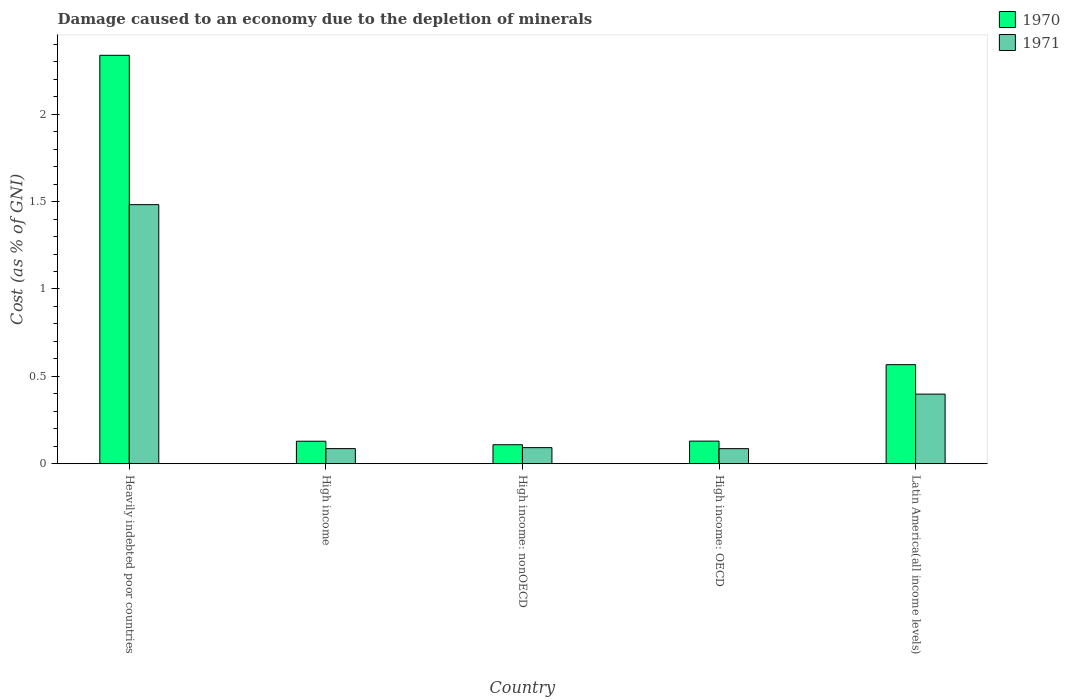How many different coloured bars are there?
Give a very brief answer. 2. Are the number of bars per tick equal to the number of legend labels?
Make the answer very short. Yes. Are the number of bars on each tick of the X-axis equal?
Give a very brief answer. Yes. What is the label of the 5th group of bars from the left?
Offer a very short reply. Latin America(all income levels). What is the cost of damage caused due to the depletion of minerals in 1971 in High income: nonOECD?
Offer a terse response. 0.09. Across all countries, what is the maximum cost of damage caused due to the depletion of minerals in 1971?
Keep it short and to the point. 1.48. Across all countries, what is the minimum cost of damage caused due to the depletion of minerals in 1970?
Your answer should be compact. 0.11. In which country was the cost of damage caused due to the depletion of minerals in 1970 maximum?
Provide a succinct answer. Heavily indebted poor countries. In which country was the cost of damage caused due to the depletion of minerals in 1971 minimum?
Make the answer very short. High income: OECD. What is the total cost of damage caused due to the depletion of minerals in 1970 in the graph?
Make the answer very short. 3.27. What is the difference between the cost of damage caused due to the depletion of minerals in 1971 in Heavily indebted poor countries and that in High income?
Ensure brevity in your answer.  1.4. What is the difference between the cost of damage caused due to the depletion of minerals in 1970 in Latin America(all income levels) and the cost of damage caused due to the depletion of minerals in 1971 in High income: nonOECD?
Offer a terse response. 0.47. What is the average cost of damage caused due to the depletion of minerals in 1971 per country?
Offer a very short reply. 0.43. What is the difference between the cost of damage caused due to the depletion of minerals of/in 1970 and cost of damage caused due to the depletion of minerals of/in 1971 in Heavily indebted poor countries?
Provide a short and direct response. 0.85. In how many countries, is the cost of damage caused due to the depletion of minerals in 1970 greater than 2.1 %?
Your answer should be very brief. 1. What is the ratio of the cost of damage caused due to the depletion of minerals in 1971 in Heavily indebted poor countries to that in High income?
Provide a succinct answer. 17.13. Is the cost of damage caused due to the depletion of minerals in 1971 in High income less than that in High income: OECD?
Offer a terse response. No. Is the difference between the cost of damage caused due to the depletion of minerals in 1970 in High income: nonOECD and Latin America(all income levels) greater than the difference between the cost of damage caused due to the depletion of minerals in 1971 in High income: nonOECD and Latin America(all income levels)?
Offer a terse response. No. What is the difference between the highest and the second highest cost of damage caused due to the depletion of minerals in 1970?
Provide a short and direct response. 0.44. What is the difference between the highest and the lowest cost of damage caused due to the depletion of minerals in 1970?
Your response must be concise. 2.23. What does the 1st bar from the left in High income: nonOECD represents?
Offer a very short reply. 1970. What does the 2nd bar from the right in High income: OECD represents?
Make the answer very short. 1970. How many bars are there?
Give a very brief answer. 10. Are all the bars in the graph horizontal?
Keep it short and to the point. No. How many countries are there in the graph?
Keep it short and to the point. 5. What is the difference between two consecutive major ticks on the Y-axis?
Make the answer very short. 0.5. Are the values on the major ticks of Y-axis written in scientific E-notation?
Provide a short and direct response. No. Where does the legend appear in the graph?
Your answer should be very brief. Top right. How many legend labels are there?
Offer a terse response. 2. How are the legend labels stacked?
Provide a succinct answer. Vertical. What is the title of the graph?
Provide a succinct answer. Damage caused to an economy due to the depletion of minerals. What is the label or title of the X-axis?
Keep it short and to the point. Country. What is the label or title of the Y-axis?
Your answer should be compact. Cost (as % of GNI). What is the Cost (as % of GNI) of 1970 in Heavily indebted poor countries?
Your answer should be very brief. 2.34. What is the Cost (as % of GNI) in 1971 in Heavily indebted poor countries?
Keep it short and to the point. 1.48. What is the Cost (as % of GNI) in 1970 in High income?
Offer a terse response. 0.13. What is the Cost (as % of GNI) in 1971 in High income?
Offer a terse response. 0.09. What is the Cost (as % of GNI) in 1970 in High income: nonOECD?
Give a very brief answer. 0.11. What is the Cost (as % of GNI) of 1971 in High income: nonOECD?
Keep it short and to the point. 0.09. What is the Cost (as % of GNI) in 1970 in High income: OECD?
Provide a succinct answer. 0.13. What is the Cost (as % of GNI) of 1971 in High income: OECD?
Offer a terse response. 0.09. What is the Cost (as % of GNI) of 1970 in Latin America(all income levels)?
Provide a succinct answer. 0.57. What is the Cost (as % of GNI) in 1971 in Latin America(all income levels)?
Give a very brief answer. 0.4. Across all countries, what is the maximum Cost (as % of GNI) of 1970?
Your response must be concise. 2.34. Across all countries, what is the maximum Cost (as % of GNI) of 1971?
Offer a very short reply. 1.48. Across all countries, what is the minimum Cost (as % of GNI) of 1970?
Keep it short and to the point. 0.11. Across all countries, what is the minimum Cost (as % of GNI) in 1971?
Keep it short and to the point. 0.09. What is the total Cost (as % of GNI) in 1970 in the graph?
Provide a succinct answer. 3.27. What is the total Cost (as % of GNI) of 1971 in the graph?
Your response must be concise. 2.15. What is the difference between the Cost (as % of GNI) in 1970 in Heavily indebted poor countries and that in High income?
Keep it short and to the point. 2.21. What is the difference between the Cost (as % of GNI) in 1971 in Heavily indebted poor countries and that in High income?
Offer a very short reply. 1.4. What is the difference between the Cost (as % of GNI) of 1970 in Heavily indebted poor countries and that in High income: nonOECD?
Your answer should be very brief. 2.23. What is the difference between the Cost (as % of GNI) of 1971 in Heavily indebted poor countries and that in High income: nonOECD?
Offer a terse response. 1.39. What is the difference between the Cost (as % of GNI) in 1970 in Heavily indebted poor countries and that in High income: OECD?
Your response must be concise. 2.21. What is the difference between the Cost (as % of GNI) of 1971 in Heavily indebted poor countries and that in High income: OECD?
Your answer should be very brief. 1.4. What is the difference between the Cost (as % of GNI) in 1970 in Heavily indebted poor countries and that in Latin America(all income levels)?
Your answer should be very brief. 1.77. What is the difference between the Cost (as % of GNI) of 1971 in Heavily indebted poor countries and that in Latin America(all income levels)?
Your answer should be compact. 1.08. What is the difference between the Cost (as % of GNI) in 1971 in High income and that in High income: nonOECD?
Offer a terse response. -0.01. What is the difference between the Cost (as % of GNI) of 1970 in High income and that in High income: OECD?
Your response must be concise. -0. What is the difference between the Cost (as % of GNI) of 1971 in High income and that in High income: OECD?
Your response must be concise. 0. What is the difference between the Cost (as % of GNI) of 1970 in High income and that in Latin America(all income levels)?
Your response must be concise. -0.44. What is the difference between the Cost (as % of GNI) of 1971 in High income and that in Latin America(all income levels)?
Ensure brevity in your answer.  -0.31. What is the difference between the Cost (as % of GNI) of 1970 in High income: nonOECD and that in High income: OECD?
Ensure brevity in your answer.  -0.02. What is the difference between the Cost (as % of GNI) of 1971 in High income: nonOECD and that in High income: OECD?
Make the answer very short. 0.01. What is the difference between the Cost (as % of GNI) of 1970 in High income: nonOECD and that in Latin America(all income levels)?
Your answer should be compact. -0.46. What is the difference between the Cost (as % of GNI) of 1971 in High income: nonOECD and that in Latin America(all income levels)?
Provide a short and direct response. -0.31. What is the difference between the Cost (as % of GNI) in 1970 in High income: OECD and that in Latin America(all income levels)?
Give a very brief answer. -0.44. What is the difference between the Cost (as % of GNI) in 1971 in High income: OECD and that in Latin America(all income levels)?
Your answer should be very brief. -0.31. What is the difference between the Cost (as % of GNI) in 1970 in Heavily indebted poor countries and the Cost (as % of GNI) in 1971 in High income?
Your answer should be compact. 2.25. What is the difference between the Cost (as % of GNI) in 1970 in Heavily indebted poor countries and the Cost (as % of GNI) in 1971 in High income: nonOECD?
Offer a very short reply. 2.25. What is the difference between the Cost (as % of GNI) in 1970 in Heavily indebted poor countries and the Cost (as % of GNI) in 1971 in High income: OECD?
Provide a succinct answer. 2.25. What is the difference between the Cost (as % of GNI) of 1970 in Heavily indebted poor countries and the Cost (as % of GNI) of 1971 in Latin America(all income levels)?
Keep it short and to the point. 1.94. What is the difference between the Cost (as % of GNI) of 1970 in High income and the Cost (as % of GNI) of 1971 in High income: nonOECD?
Provide a succinct answer. 0.04. What is the difference between the Cost (as % of GNI) in 1970 in High income and the Cost (as % of GNI) in 1971 in High income: OECD?
Offer a terse response. 0.04. What is the difference between the Cost (as % of GNI) in 1970 in High income and the Cost (as % of GNI) in 1971 in Latin America(all income levels)?
Provide a succinct answer. -0.27. What is the difference between the Cost (as % of GNI) in 1970 in High income: nonOECD and the Cost (as % of GNI) in 1971 in High income: OECD?
Make the answer very short. 0.02. What is the difference between the Cost (as % of GNI) in 1970 in High income: nonOECD and the Cost (as % of GNI) in 1971 in Latin America(all income levels)?
Ensure brevity in your answer.  -0.29. What is the difference between the Cost (as % of GNI) of 1970 in High income: OECD and the Cost (as % of GNI) of 1971 in Latin America(all income levels)?
Offer a very short reply. -0.27. What is the average Cost (as % of GNI) in 1970 per country?
Offer a terse response. 0.65. What is the average Cost (as % of GNI) of 1971 per country?
Offer a terse response. 0.43. What is the difference between the Cost (as % of GNI) of 1970 and Cost (as % of GNI) of 1971 in Heavily indebted poor countries?
Give a very brief answer. 0.85. What is the difference between the Cost (as % of GNI) of 1970 and Cost (as % of GNI) of 1971 in High income?
Offer a very short reply. 0.04. What is the difference between the Cost (as % of GNI) of 1970 and Cost (as % of GNI) of 1971 in High income: nonOECD?
Provide a short and direct response. 0.02. What is the difference between the Cost (as % of GNI) in 1970 and Cost (as % of GNI) in 1971 in High income: OECD?
Keep it short and to the point. 0.04. What is the difference between the Cost (as % of GNI) of 1970 and Cost (as % of GNI) of 1971 in Latin America(all income levels)?
Provide a short and direct response. 0.17. What is the ratio of the Cost (as % of GNI) in 1970 in Heavily indebted poor countries to that in High income?
Offer a terse response. 18.15. What is the ratio of the Cost (as % of GNI) in 1971 in Heavily indebted poor countries to that in High income?
Your answer should be very brief. 17.13. What is the ratio of the Cost (as % of GNI) of 1970 in Heavily indebted poor countries to that in High income: nonOECD?
Offer a very short reply. 21.48. What is the ratio of the Cost (as % of GNI) in 1971 in Heavily indebted poor countries to that in High income: nonOECD?
Provide a succinct answer. 16.08. What is the ratio of the Cost (as % of GNI) in 1970 in Heavily indebted poor countries to that in High income: OECD?
Keep it short and to the point. 18.06. What is the ratio of the Cost (as % of GNI) of 1971 in Heavily indebted poor countries to that in High income: OECD?
Your answer should be compact. 17.17. What is the ratio of the Cost (as % of GNI) in 1970 in Heavily indebted poor countries to that in Latin America(all income levels)?
Provide a short and direct response. 4.12. What is the ratio of the Cost (as % of GNI) in 1971 in Heavily indebted poor countries to that in Latin America(all income levels)?
Provide a succinct answer. 3.72. What is the ratio of the Cost (as % of GNI) of 1970 in High income to that in High income: nonOECD?
Offer a terse response. 1.18. What is the ratio of the Cost (as % of GNI) of 1971 in High income to that in High income: nonOECD?
Your response must be concise. 0.94. What is the ratio of the Cost (as % of GNI) in 1970 in High income to that in High income: OECD?
Keep it short and to the point. 1. What is the ratio of the Cost (as % of GNI) in 1970 in High income to that in Latin America(all income levels)?
Offer a terse response. 0.23. What is the ratio of the Cost (as % of GNI) of 1971 in High income to that in Latin America(all income levels)?
Make the answer very short. 0.22. What is the ratio of the Cost (as % of GNI) of 1970 in High income: nonOECD to that in High income: OECD?
Ensure brevity in your answer.  0.84. What is the ratio of the Cost (as % of GNI) of 1971 in High income: nonOECD to that in High income: OECD?
Offer a very short reply. 1.07. What is the ratio of the Cost (as % of GNI) of 1970 in High income: nonOECD to that in Latin America(all income levels)?
Keep it short and to the point. 0.19. What is the ratio of the Cost (as % of GNI) of 1971 in High income: nonOECD to that in Latin America(all income levels)?
Ensure brevity in your answer.  0.23. What is the ratio of the Cost (as % of GNI) in 1970 in High income: OECD to that in Latin America(all income levels)?
Offer a very short reply. 0.23. What is the ratio of the Cost (as % of GNI) in 1971 in High income: OECD to that in Latin America(all income levels)?
Make the answer very short. 0.22. What is the difference between the highest and the second highest Cost (as % of GNI) in 1970?
Keep it short and to the point. 1.77. What is the difference between the highest and the second highest Cost (as % of GNI) of 1971?
Your response must be concise. 1.08. What is the difference between the highest and the lowest Cost (as % of GNI) in 1970?
Your answer should be compact. 2.23. What is the difference between the highest and the lowest Cost (as % of GNI) of 1971?
Your response must be concise. 1.4. 